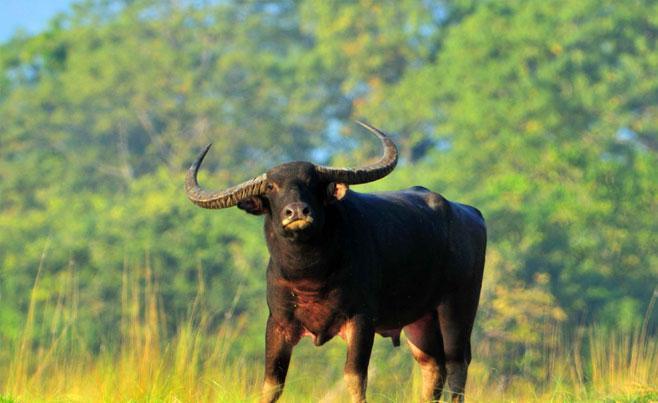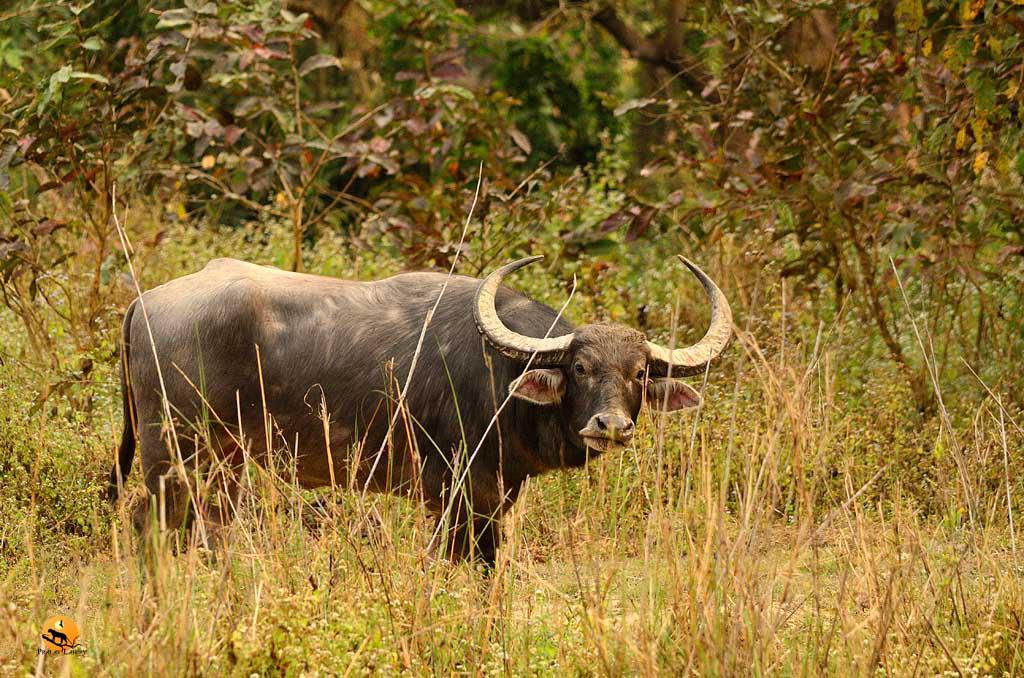The first image is the image on the left, the second image is the image on the right. Examine the images to the left and right. Is the description "At least one of the images contains more than one water buffalo." accurate? Answer yes or no. No. The first image is the image on the left, the second image is the image on the right. Considering the images on both sides, is "Left image contains one dark water buffalo with light coloring on its lower legs, and its head turned to look directly at the camera." valid? Answer yes or no. Yes. 